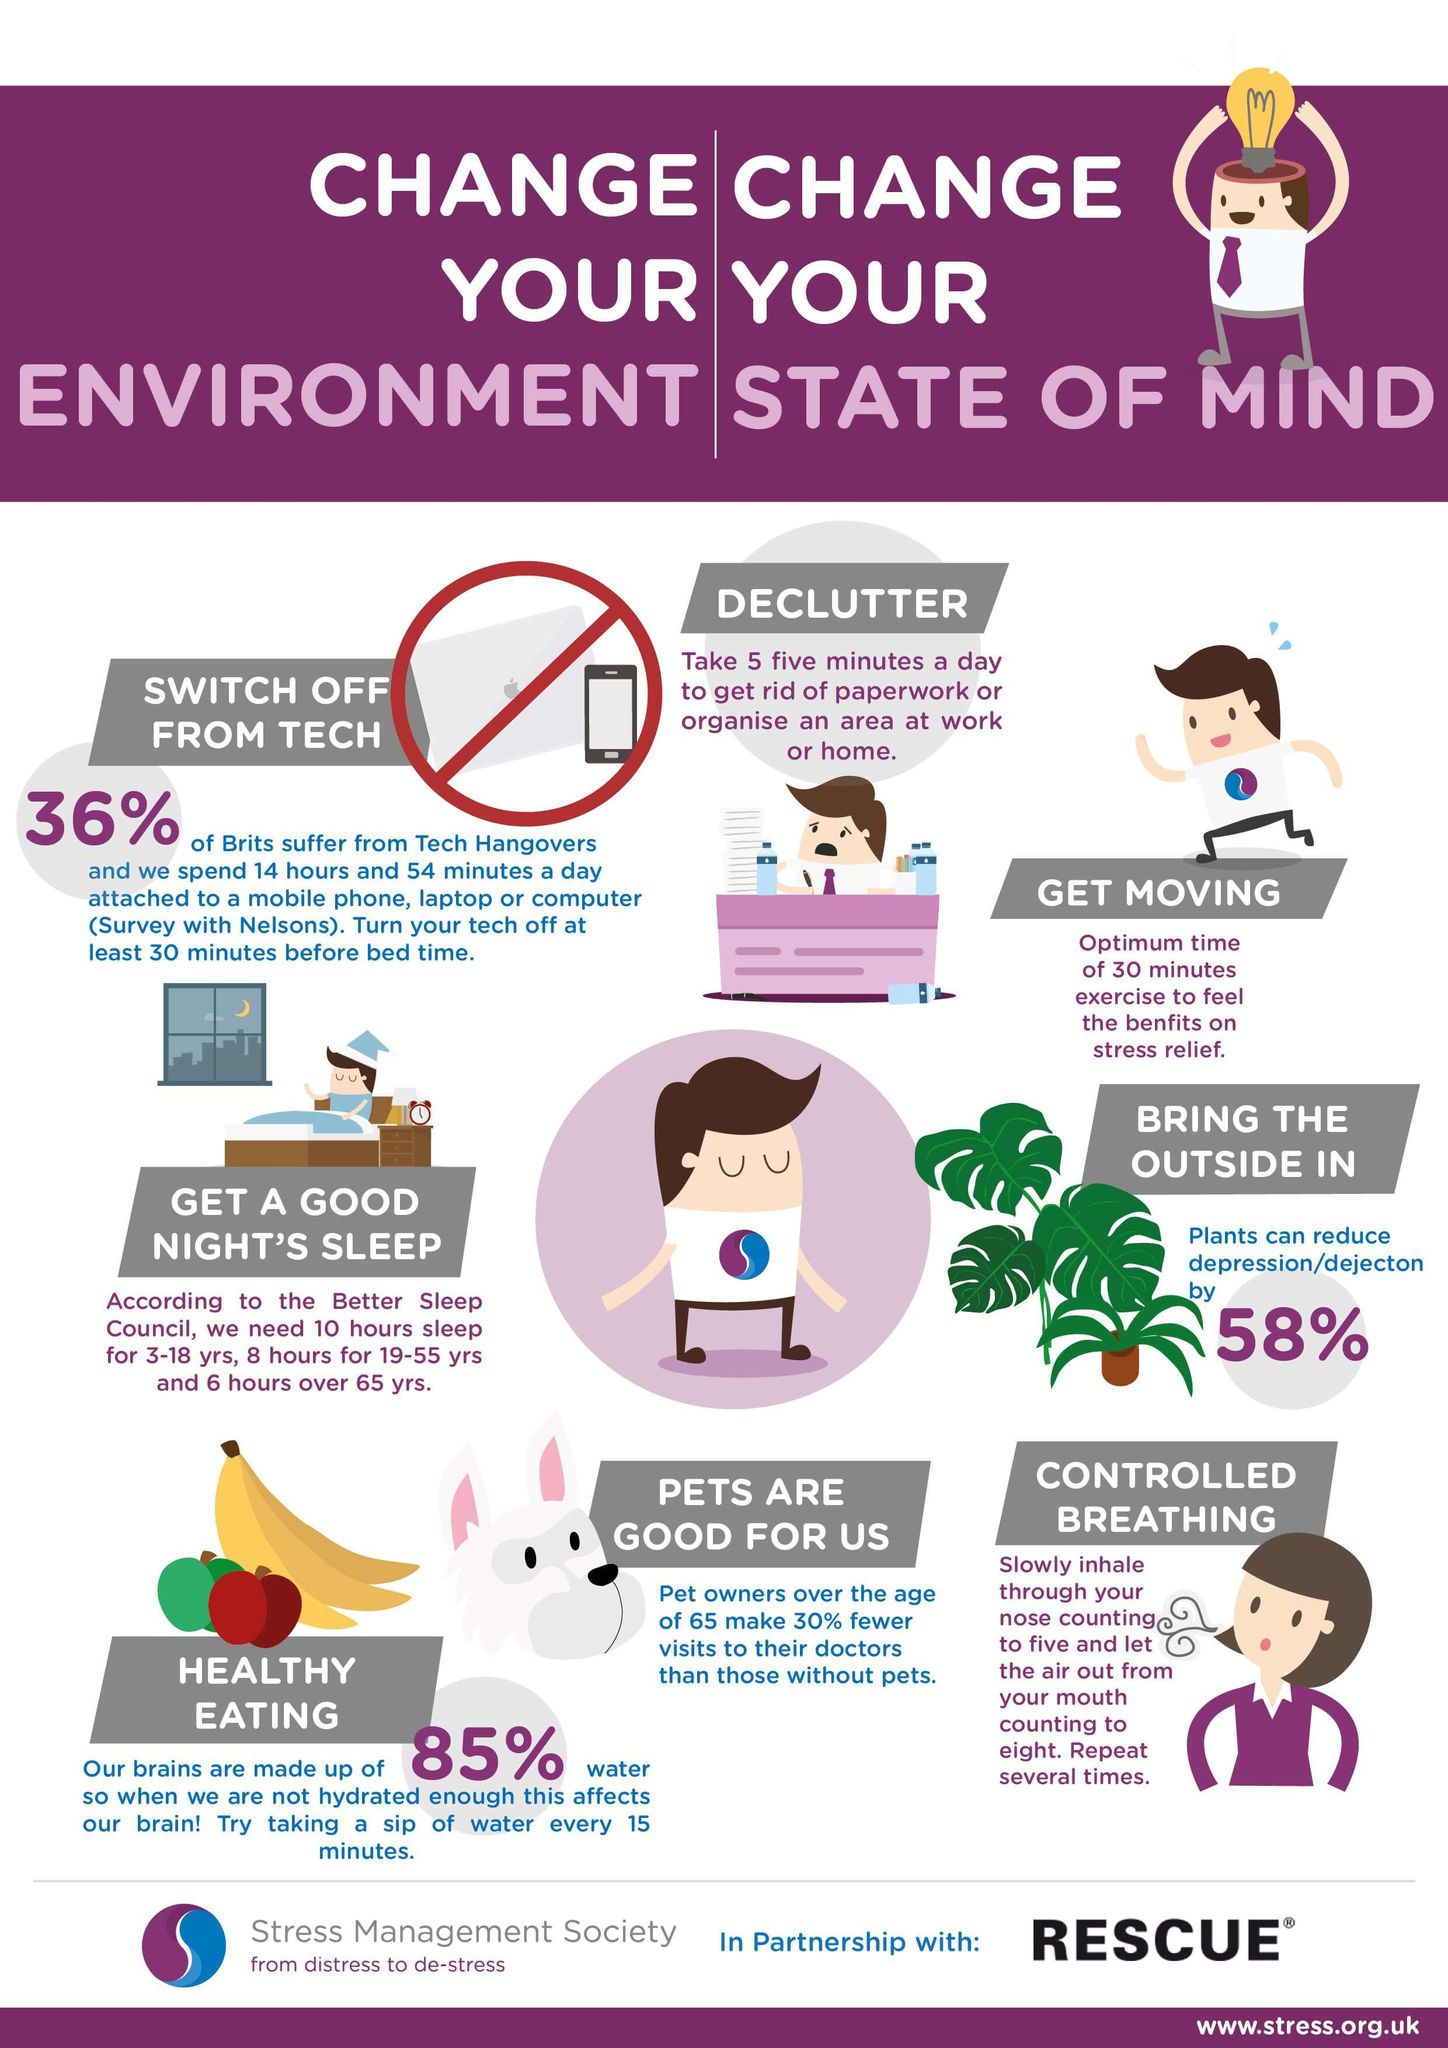What needs to be avoided before going to sleep, breathing exercises, healthy food, or electronic gadgets?
Answer the question with a short phrase. electronic gadgets What is the percentage of cerebrospinal fluid, 36%, 58%, or 85%? 85% 